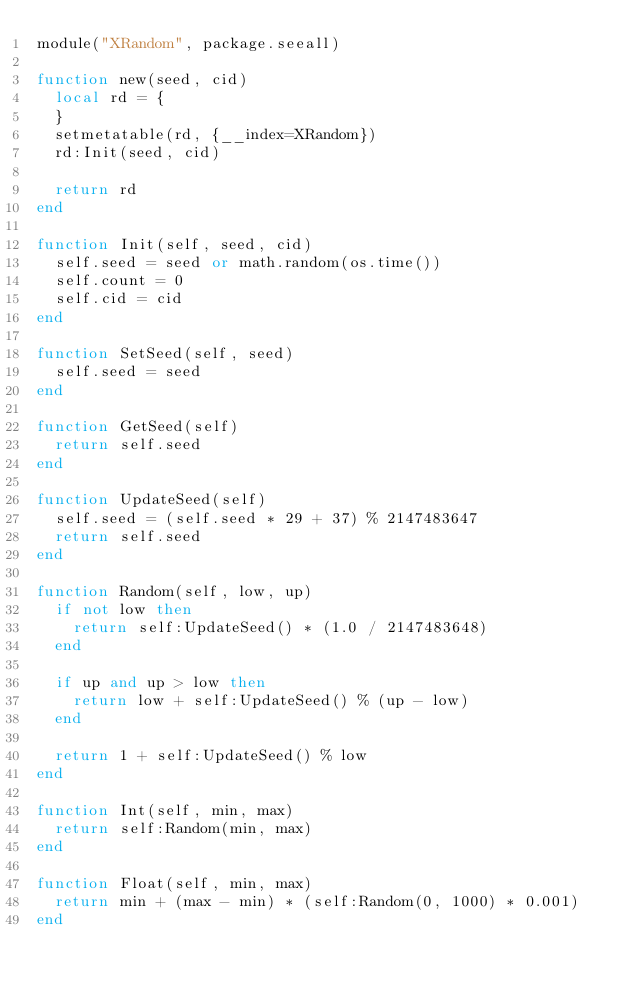<code> <loc_0><loc_0><loc_500><loc_500><_Lua_>module("XRandom", package.seeall)

function new(seed, cid)
	local rd = {
	}
	setmetatable(rd, {__index=XRandom})
	rd:Init(seed, cid)

	return rd
end

function Init(self, seed, cid)
	self.seed = seed or math.random(os.time())
	self.count = 0
	self.cid = cid
end

function SetSeed(self, seed)
	self.seed = seed
end

function GetSeed(self)
	return self.seed
end

function UpdateSeed(self)
	self.seed = (self.seed * 29 + 37) % 2147483647
	return self.seed
end

function Random(self, low, up)
	if not low then
		return self:UpdateSeed() * (1.0 / 2147483648)
	end

	if up and up > low then
		return low + self:UpdateSeed() % (up - low)
	end

	return 1 + self:UpdateSeed() % low
end

function Int(self, min, max)
	return self:Random(min, max)
end

function Float(self, min, max)
	return min + (max - min) * (self:Random(0, 1000) * 0.001)
end</code> 